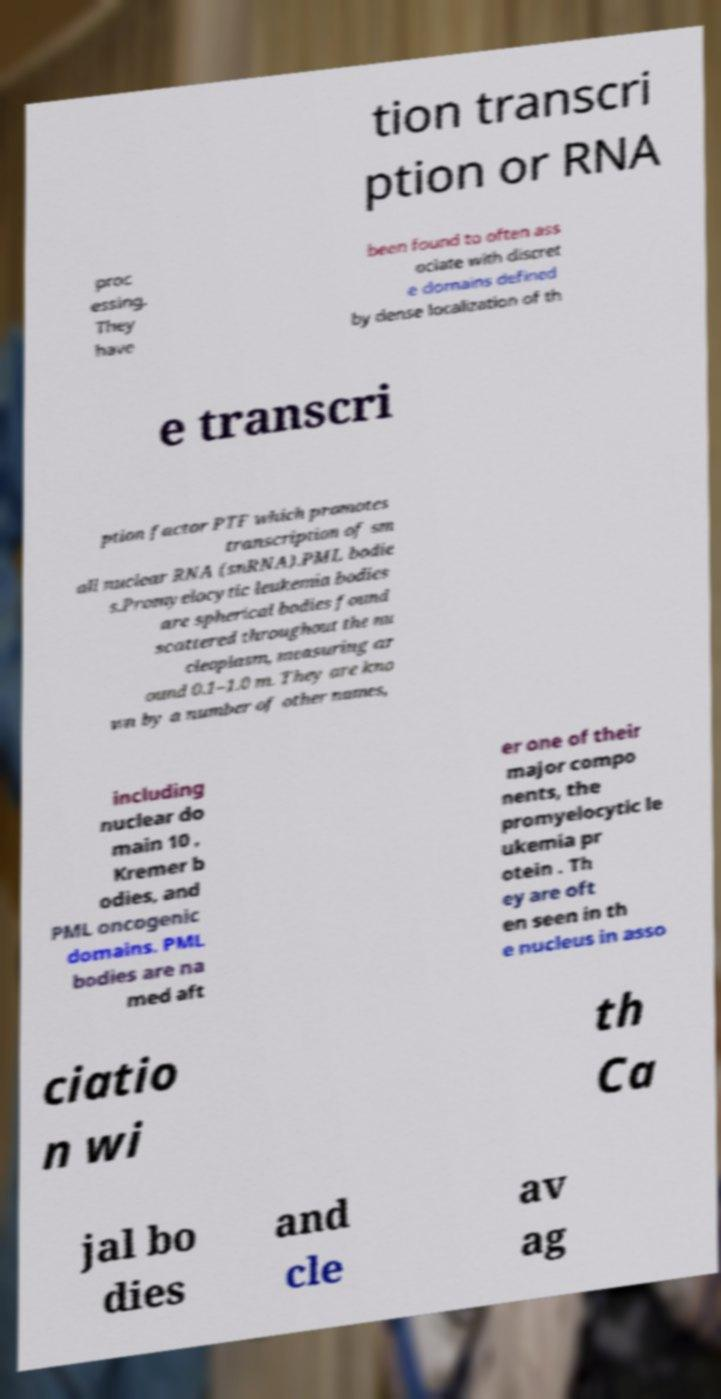What messages or text are displayed in this image? I need them in a readable, typed format. tion transcri ption or RNA proc essing. They have been found to often ass ociate with discret e domains defined by dense localization of th e transcri ption factor PTF which promotes transcription of sm all nuclear RNA (snRNA).PML bodie s.Promyelocytic leukemia bodies are spherical bodies found scattered throughout the nu cleoplasm, measuring ar ound 0.1–1.0 m. They are kno wn by a number of other names, including nuclear do main 10 , Kremer b odies, and PML oncogenic domains. PML bodies are na med aft er one of their major compo nents, the promyelocytic le ukemia pr otein . Th ey are oft en seen in th e nucleus in asso ciatio n wi th Ca jal bo dies and cle av ag 